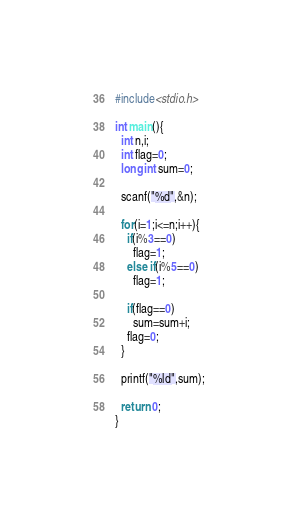Convert code to text. <code><loc_0><loc_0><loc_500><loc_500><_C_>#include<stdio.h>
 
int main(){
  int n,i;
  int flag=0;
  long int sum=0;
  
  scanf("%d",&n);
  
  for(i=1;i<=n;i++){
    if(i%3==0)
      flag=1;
    else if(i%5==0)
      flag=1;
    
    if(flag==0)
      sum=sum+i;
    flag=0;
  }
  
  printf("%ld",sum);
  
  return 0;
}</code> 